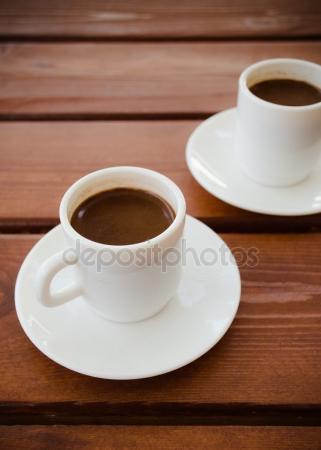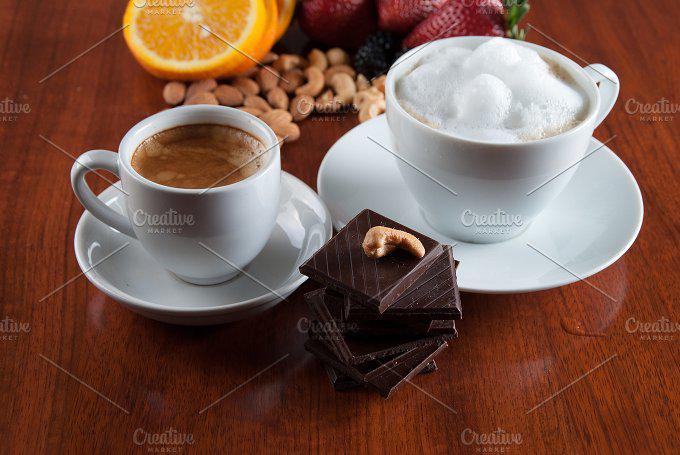The first image is the image on the left, the second image is the image on the right. Considering the images on both sides, is "Two cups for hot drinks are in each image, each sitting on a matching saucer." valid? Answer yes or no. Yes. The first image is the image on the left, the second image is the image on the right. Examine the images to the left and right. Is the description "Left image shows two cups of the same beverages on white saucers." accurate? Answer yes or no. Yes. The first image is the image on the left, the second image is the image on the right. Analyze the images presented: Is the assertion "There are four tea cups sitting  on saucers." valid? Answer yes or no. Yes. The first image is the image on the left, the second image is the image on the right. For the images displayed, is the sentence "One image appears to depict two completely empty cups." factually correct? Answer yes or no. No. 